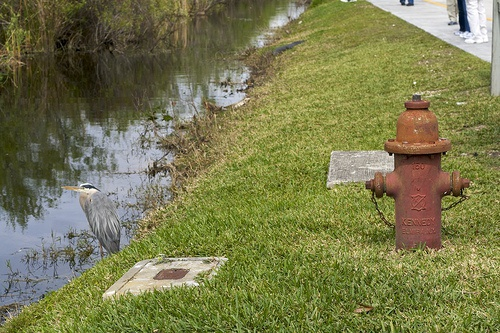Describe the objects in this image and their specific colors. I can see fire hydrant in black and brown tones, bird in black, darkgray, gray, lightgray, and tan tones, people in black, white, darkgray, and lightgray tones, people in black, navy, lavender, and darkblue tones, and people in black, darkgray, gray, and lightgray tones in this image. 